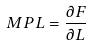<formula> <loc_0><loc_0><loc_500><loc_500>M P L = \frac { \partial F } { \partial L }</formula> 